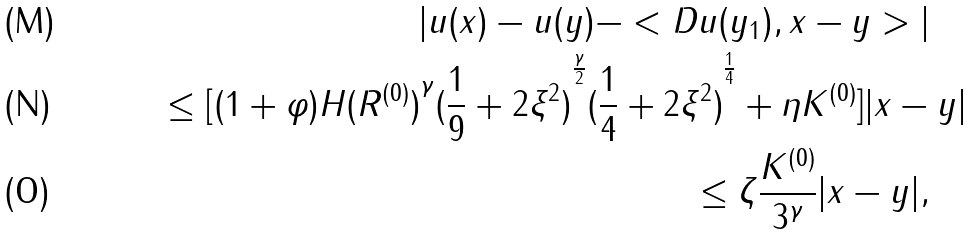Convert formula to latex. <formula><loc_0><loc_0><loc_500><loc_500>| u ( x ) - u ( y ) - < D u ( y _ { 1 } ) , x - y > | \quad \\ \leq [ ( 1 + \varphi ) H { ( R ^ { ( 0 ) } ) } ^ { \gamma } { ( \frac { 1 } { 9 } + 2 \xi ^ { 2 } ) } ^ { \frac { \gamma } { 2 } } { ( \frac { 1 } { 4 } + 2 \xi ^ { 2 } ) } ^ { \frac { 1 } { 4 } } + \eta K ^ { ( 0 ) } ] | x - y | \\ \leq \zeta \frac { K ^ { ( 0 ) } } { 3 ^ { \gamma } } | x - y | , \quad</formula> 